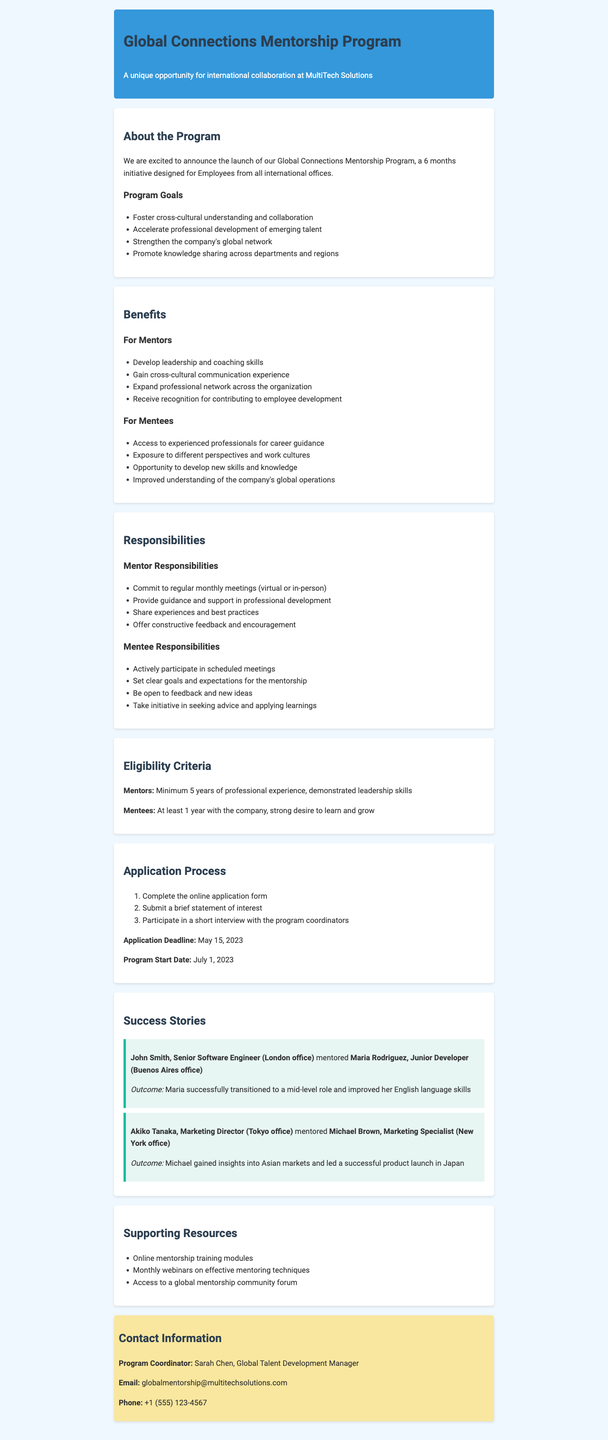What is the name of the program? The program is referred to as the Global Connections Mentorship Program in the document.
Answer: Global Connections Mentorship Program How long is the program duration? The document states that the program duration is 6 months.
Answer: 6 months Who is the program coordinator? The document lists Sarah Chen as the Global Talent Development Manager as the program coordinator.
Answer: Sarah Chen When is the application deadline? The document specifies that the application deadline is May 15, 2023.
Answer: May 15, 2023 What are mentors expected to provide as part of their responsibilities? Responsibilities for mentors include providing guidance and support in professional development as outlined in the document.
Answer: Guidance and support in professional development What is one benefit for mentees? The document mentions that mentees will have access to experienced professionals for career guidance as a benefit.
Answer: Access to experienced professionals for career guidance What is one success story outcome? The document highlights that Maria successfully transitioned to a mid-level role and improved her English language skills as a success story.
Answer: Maria successfully transitioned to a mid-level role and improved her English language skills How many steps are in the application process? The document mentions three steps in the application process.
Answer: Three steps 